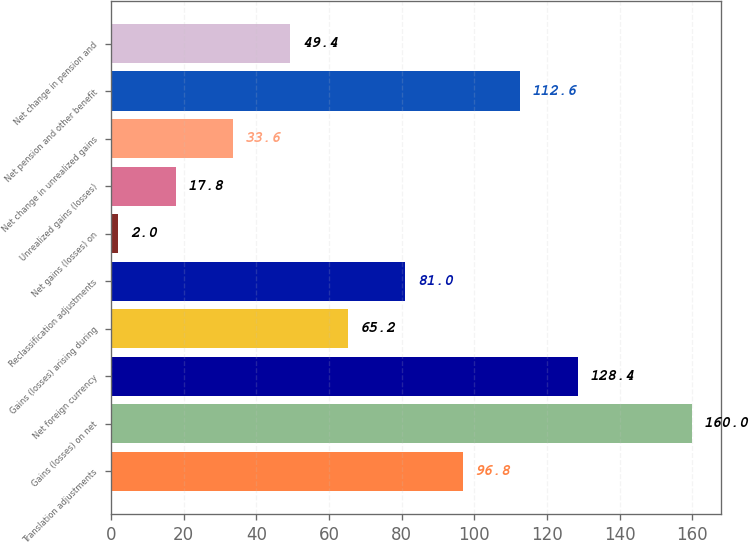Convert chart to OTSL. <chart><loc_0><loc_0><loc_500><loc_500><bar_chart><fcel>Translation adjustments<fcel>Gains (losses) on net<fcel>Net foreign currency<fcel>Gains (losses) arising during<fcel>Reclassification adjustments<fcel>Net gains (losses) on<fcel>Unrealized gains (losses)<fcel>Net change in unrealized gains<fcel>Net pension and other benefit<fcel>Net change in pension and<nl><fcel>96.8<fcel>160<fcel>128.4<fcel>65.2<fcel>81<fcel>2<fcel>17.8<fcel>33.6<fcel>112.6<fcel>49.4<nl></chart> 